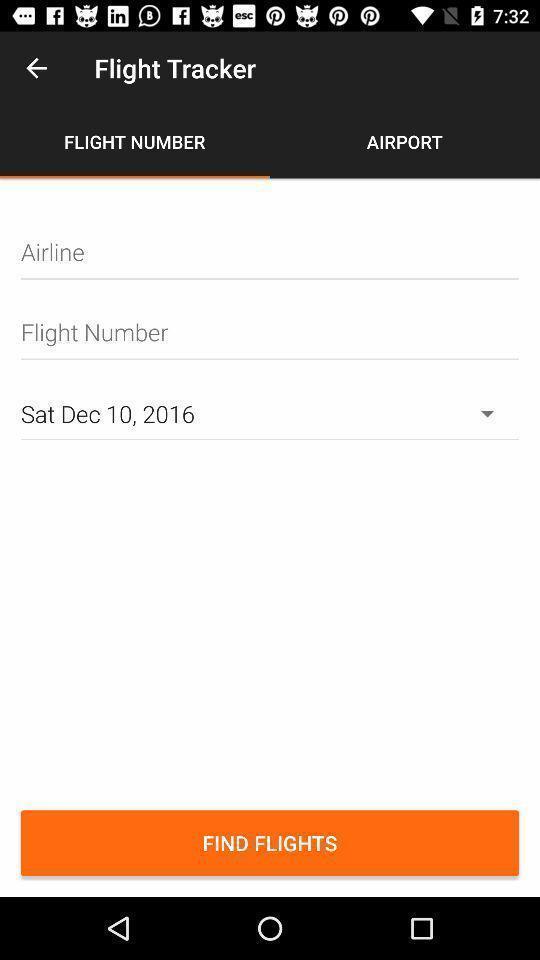Give me a narrative description of this picture. Screen displaying multiple options in an airline tracking application. 